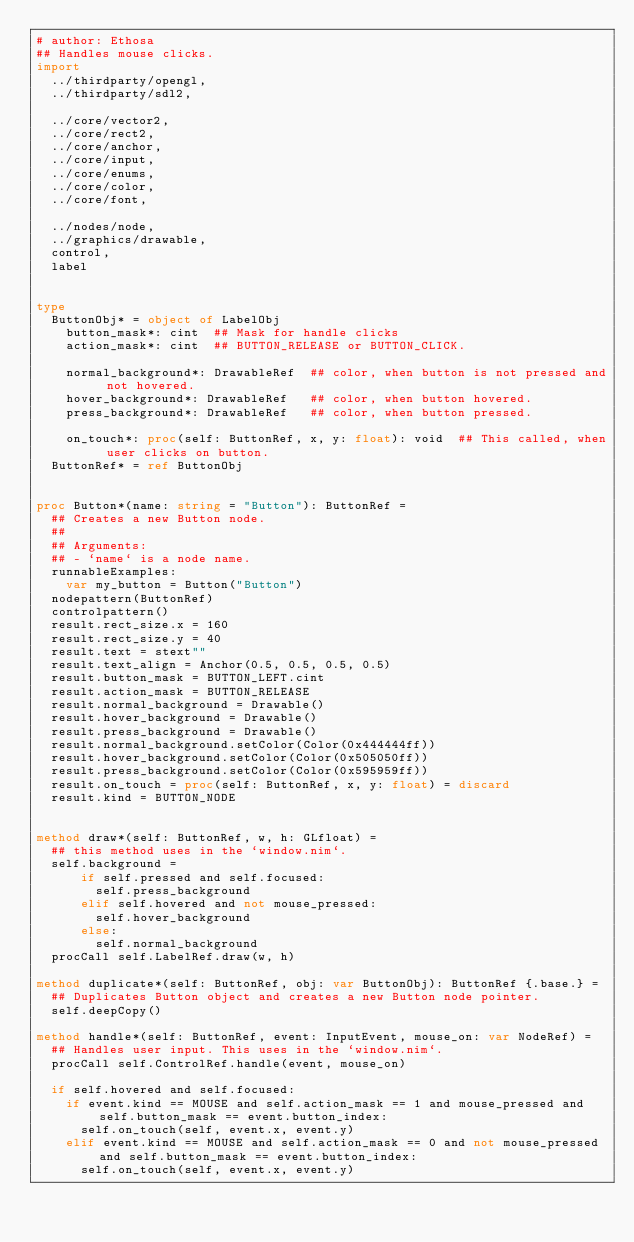<code> <loc_0><loc_0><loc_500><loc_500><_Nim_># author: Ethosa
## Handles mouse clicks.
import
  ../thirdparty/opengl,
  ../thirdparty/sdl2,

  ../core/vector2,
  ../core/rect2,
  ../core/anchor,
  ../core/input,
  ../core/enums,
  ../core/color,
  ../core/font,

  ../nodes/node,
  ../graphics/drawable,
  control,
  label


type
  ButtonObj* = object of LabelObj
    button_mask*: cint  ## Mask for handle clicks
    action_mask*: cint  ## BUTTON_RELEASE or BUTTON_CLICK.

    normal_background*: DrawableRef  ## color, when button is not pressed and not hovered.
    hover_background*: DrawableRef   ## color, when button hovered.
    press_background*: DrawableRef   ## color, when button pressed.

    on_touch*: proc(self: ButtonRef, x, y: float): void  ## This called, when user clicks on button.
  ButtonRef* = ref ButtonObj


proc Button*(name: string = "Button"): ButtonRef =
  ## Creates a new Button node.
  ##
  ## Arguments:
  ## - `name` is a node name.
  runnableExamples:
    var my_button = Button("Button")
  nodepattern(ButtonRef)
  controlpattern()
  result.rect_size.x = 160
  result.rect_size.y = 40
  result.text = stext""
  result.text_align = Anchor(0.5, 0.5, 0.5, 0.5)
  result.button_mask = BUTTON_LEFT.cint
  result.action_mask = BUTTON_RELEASE
  result.normal_background = Drawable()
  result.hover_background = Drawable()
  result.press_background = Drawable()
  result.normal_background.setColor(Color(0x444444ff))
  result.hover_background.setColor(Color(0x505050ff))
  result.press_background.setColor(Color(0x595959ff))
  result.on_touch = proc(self: ButtonRef, x, y: float) = discard
  result.kind = BUTTON_NODE


method draw*(self: ButtonRef, w, h: GLfloat) =
  ## this method uses in the `window.nim`.
  self.background =
      if self.pressed and self.focused:
        self.press_background
      elif self.hovered and not mouse_pressed:
        self.hover_background
      else:
        self.normal_background
  procCall self.LabelRef.draw(w, h)

method duplicate*(self: ButtonRef, obj: var ButtonObj): ButtonRef {.base.} =
  ## Duplicates Button object and creates a new Button node pointer.
  self.deepCopy()

method handle*(self: ButtonRef, event: InputEvent, mouse_on: var NodeRef) =
  ## Handles user input. This uses in the `window.nim`.
  procCall self.ControlRef.handle(event, mouse_on)

  if self.hovered and self.focused:
    if event.kind == MOUSE and self.action_mask == 1 and mouse_pressed and self.button_mask == event.button_index:
      self.on_touch(self, event.x, event.y)
    elif event.kind == MOUSE and self.action_mask == 0 and not mouse_pressed and self.button_mask == event.button_index:
      self.on_touch(self, event.x, event.y)
</code> 